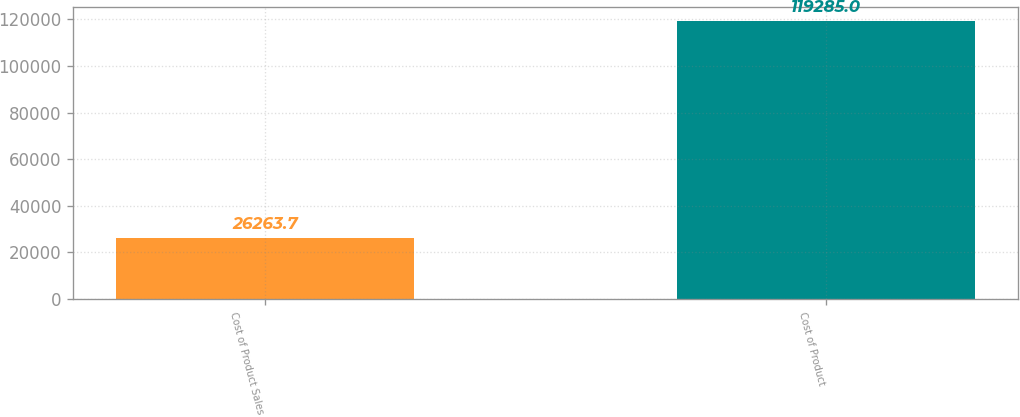Convert chart to OTSL. <chart><loc_0><loc_0><loc_500><loc_500><bar_chart><fcel>Cost of Product Sales<fcel>Cost of Product<nl><fcel>26263.7<fcel>119285<nl></chart> 